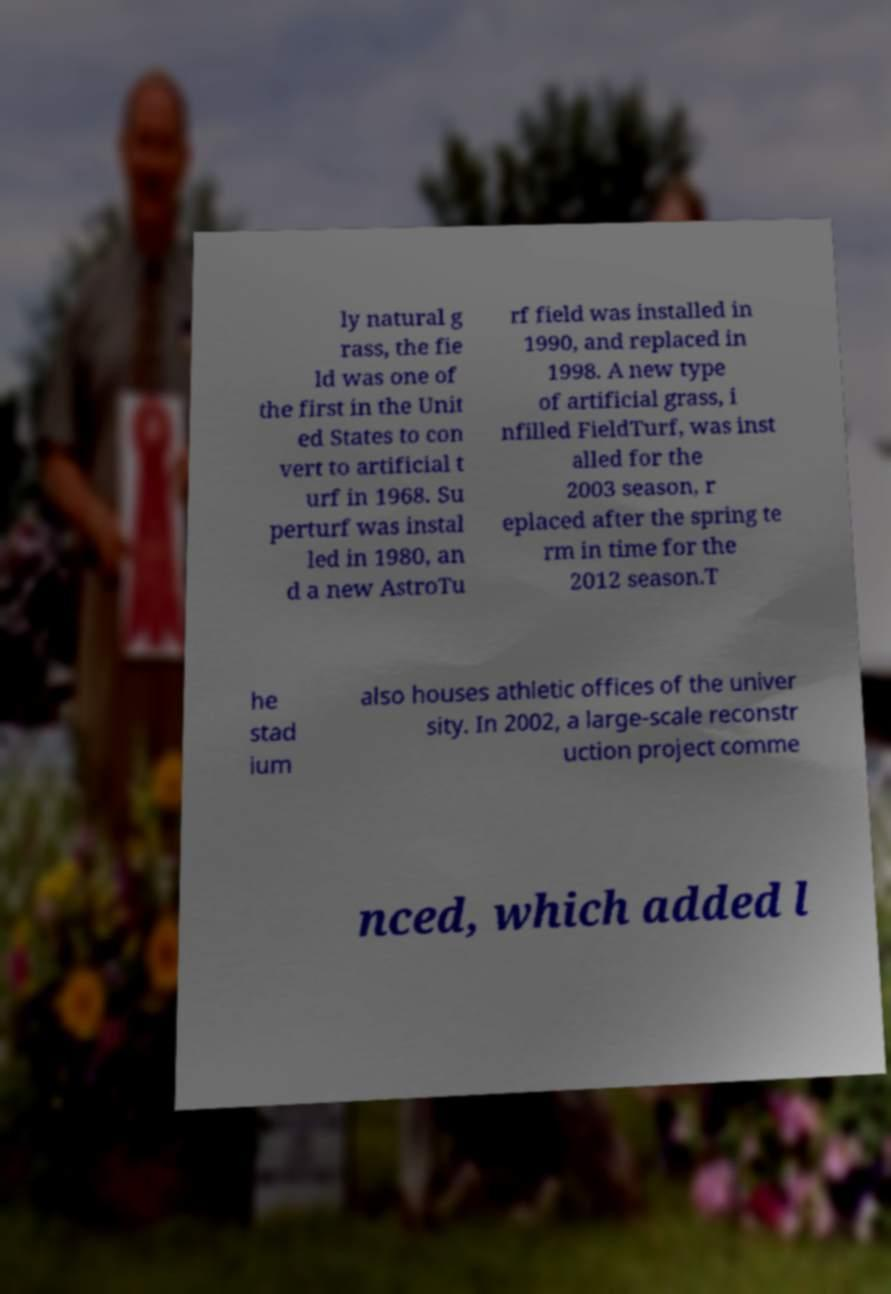There's text embedded in this image that I need extracted. Can you transcribe it verbatim? ly natural g rass, the fie ld was one of the first in the Unit ed States to con vert to artificial t urf in 1968. Su perturf was instal led in 1980, an d a new AstroTu rf field was installed in 1990, and replaced in 1998. A new type of artificial grass, i nfilled FieldTurf, was inst alled for the 2003 season, r eplaced after the spring te rm in time for the 2012 season.T he stad ium also houses athletic offices of the univer sity. In 2002, a large-scale reconstr uction project comme nced, which added l 